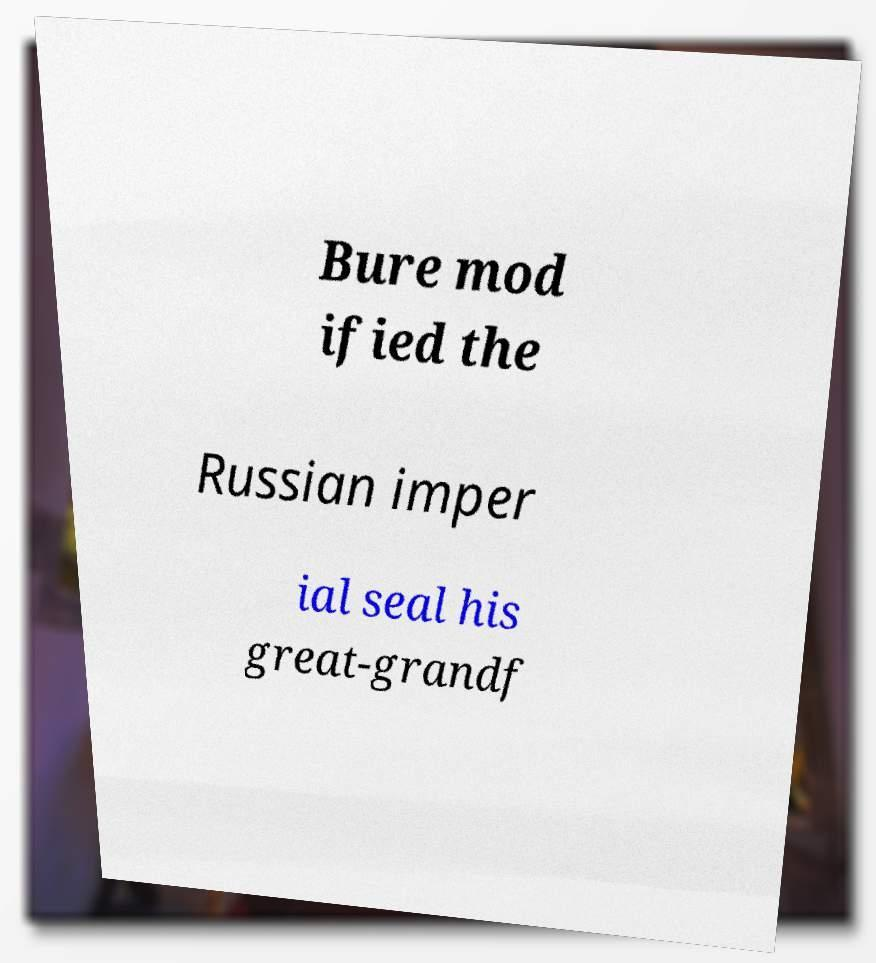There's text embedded in this image that I need extracted. Can you transcribe it verbatim? Bure mod ified the Russian imper ial seal his great-grandf 